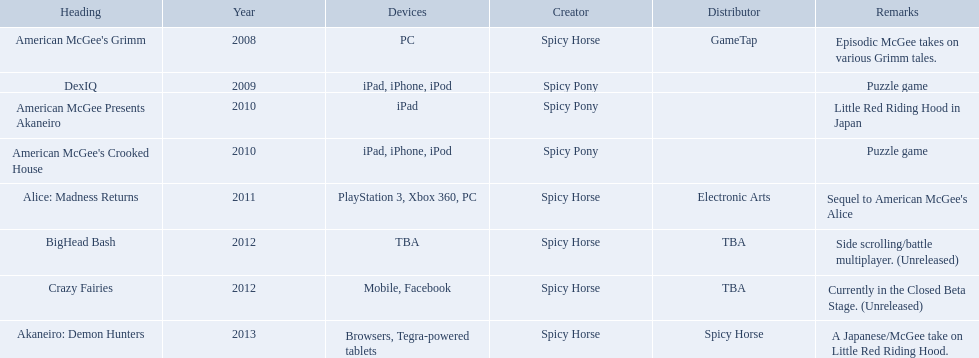Which spicy horse titles are shown? American McGee's Grimm, DexIQ, American McGee Presents Akaneiro, American McGee's Crooked House, Alice: Madness Returns, BigHead Bash, Crazy Fairies, Akaneiro: Demon Hunters. Of those, which are for the ipad? DexIQ, American McGee Presents Akaneiro, American McGee's Crooked House. Which of those are not for the iphone or ipod? American McGee Presents Akaneiro. What are all of the game titles? American McGee's Grimm, DexIQ, American McGee Presents Akaneiro, American McGee's Crooked House, Alice: Madness Returns, BigHead Bash, Crazy Fairies, Akaneiro: Demon Hunters. Which developer developed a game in 2011? Spicy Horse. Who published this game in 2011 Electronic Arts. What was the name of this published game in 2011? Alice: Madness Returns. 